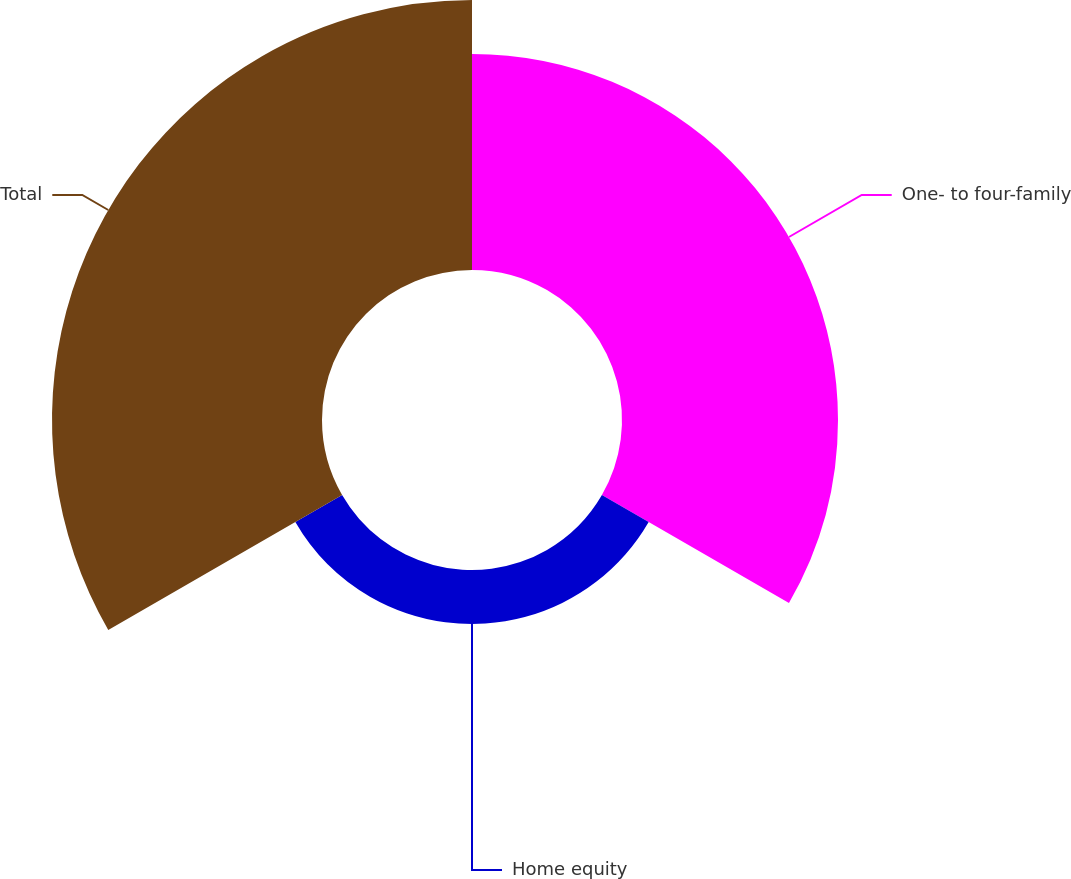Convert chart to OTSL. <chart><loc_0><loc_0><loc_500><loc_500><pie_chart><fcel>One- to four-family<fcel>Home equity<fcel>Total<nl><fcel>40.0%<fcel>10.0%<fcel>50.0%<nl></chart> 